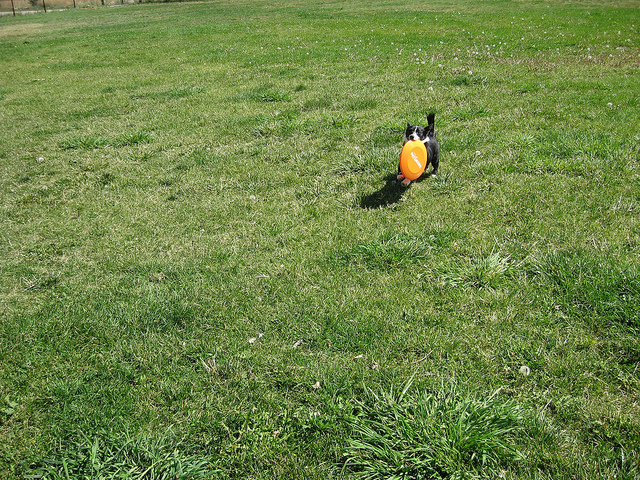<image>How old is the dog? It is unanswerable to determine the exact age of the dog. How old is the dog? The age of the dog is uncertain. It can be seen as a puppy and around 1 or 2 years old. 